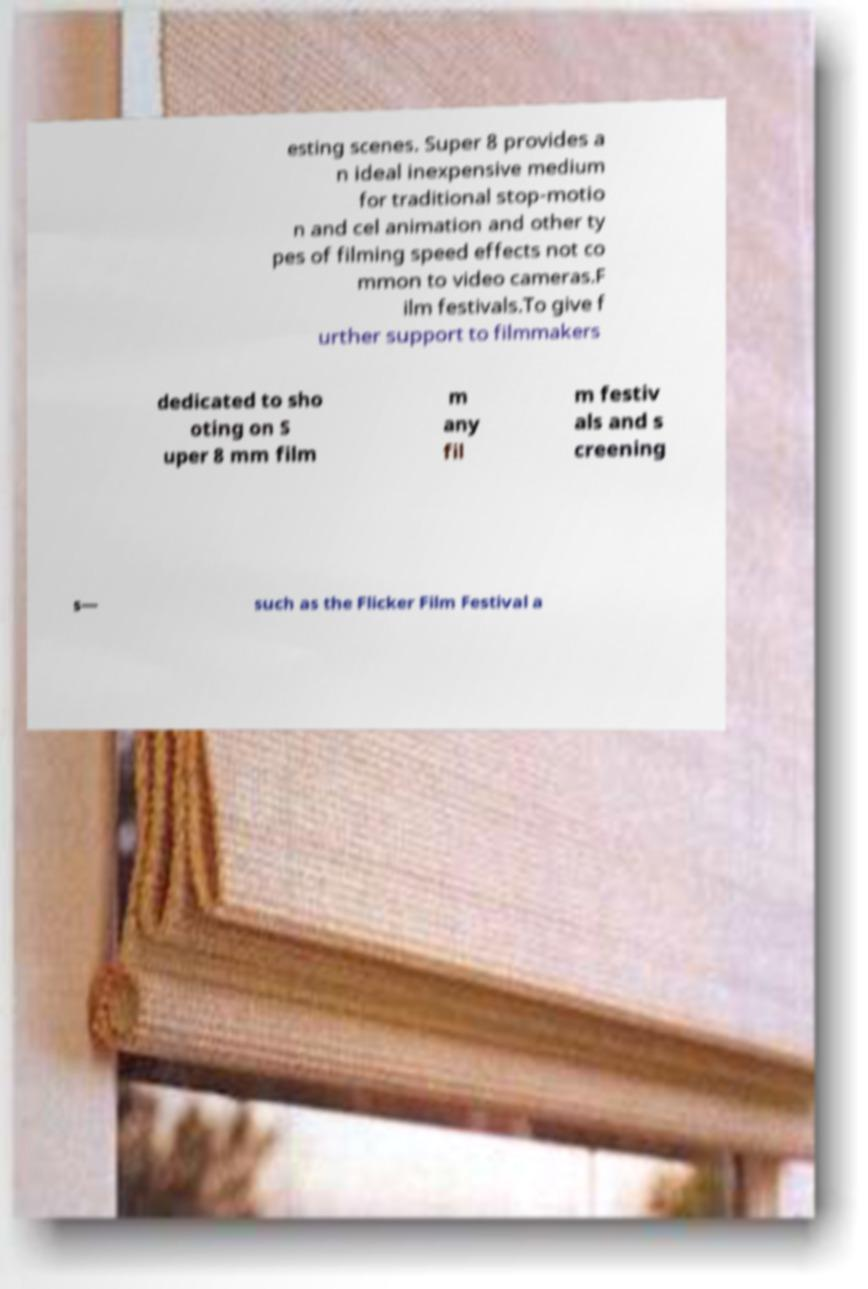Please identify and transcribe the text found in this image. esting scenes. Super 8 provides a n ideal inexpensive medium for traditional stop-motio n and cel animation and other ty pes of filming speed effects not co mmon to video cameras.F ilm festivals.To give f urther support to filmmakers dedicated to sho oting on S uper 8 mm film m any fil m festiv als and s creening s— such as the Flicker Film Festival a 